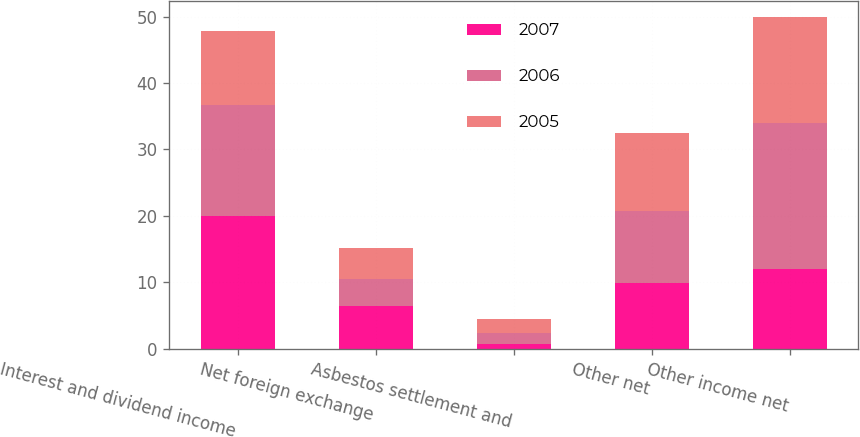<chart> <loc_0><loc_0><loc_500><loc_500><stacked_bar_chart><ecel><fcel>Interest and dividend income<fcel>Net foreign exchange<fcel>Asbestos settlement and<fcel>Other net<fcel>Other income net<nl><fcel>2007<fcel>19.9<fcel>6.4<fcel>0.7<fcel>9.8<fcel>12<nl><fcel>2006<fcel>16.8<fcel>4.1<fcel>1.6<fcel>10.9<fcel>22<nl><fcel>2005<fcel>11.1<fcel>4.7<fcel>2.2<fcel>11.7<fcel>15.9<nl></chart> 